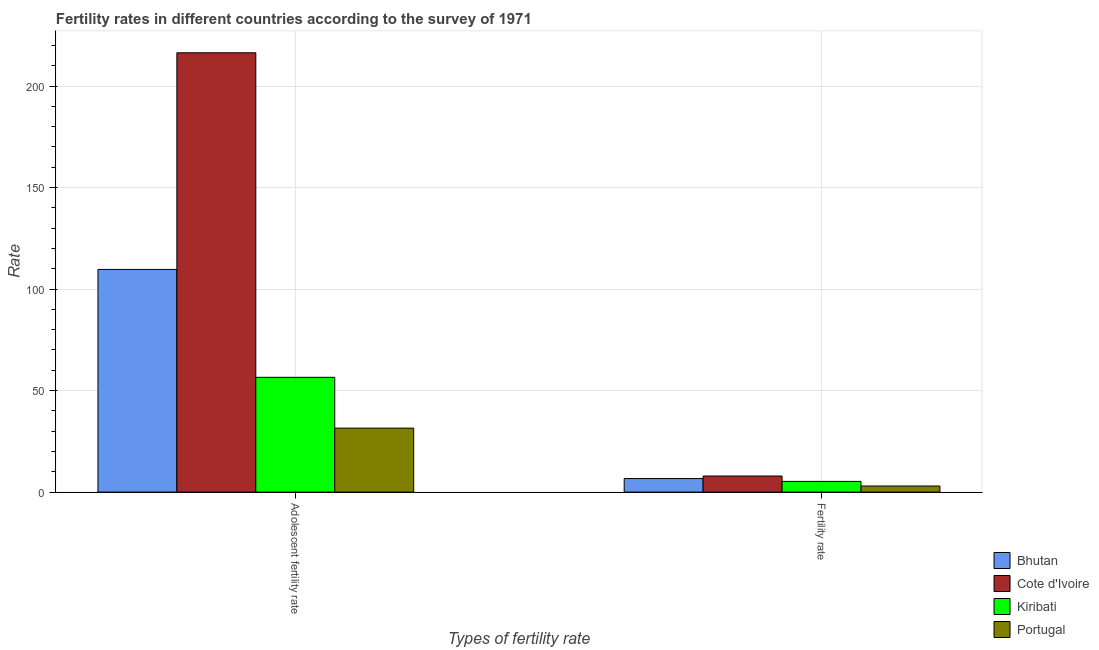Are the number of bars per tick equal to the number of legend labels?
Give a very brief answer. Yes. How many bars are there on the 1st tick from the right?
Ensure brevity in your answer.  4. What is the label of the 1st group of bars from the left?
Your response must be concise. Adolescent fertility rate. What is the adolescent fertility rate in Kiribati?
Ensure brevity in your answer.  56.53. Across all countries, what is the maximum fertility rate?
Offer a very short reply. 7.93. Across all countries, what is the minimum adolescent fertility rate?
Offer a very short reply. 31.51. In which country was the fertility rate maximum?
Your response must be concise. Cote d'Ivoire. What is the total fertility rate in the graph?
Your response must be concise. 22.87. What is the difference between the fertility rate in Portugal and that in Bhutan?
Your response must be concise. -3.67. What is the difference between the fertility rate in Kiribati and the adolescent fertility rate in Portugal?
Provide a succinct answer. -26.24. What is the average adolescent fertility rate per country?
Provide a succinct answer. 103.53. What is the difference between the adolescent fertility rate and fertility rate in Portugal?
Give a very brief answer. 28.51. In how many countries, is the adolescent fertility rate greater than 180 ?
Make the answer very short. 1. What is the ratio of the adolescent fertility rate in Cote d'Ivoire to that in Kiribati?
Make the answer very short. 3.83. Is the adolescent fertility rate in Cote d'Ivoire less than that in Bhutan?
Offer a very short reply. No. In how many countries, is the fertility rate greater than the average fertility rate taken over all countries?
Offer a terse response. 2. What does the 3rd bar from the left in Fertility rate represents?
Your answer should be compact. Kiribati. What does the 4th bar from the right in Fertility rate represents?
Ensure brevity in your answer.  Bhutan. How many bars are there?
Keep it short and to the point. 8. Are all the bars in the graph horizontal?
Offer a very short reply. No. What is the difference between two consecutive major ticks on the Y-axis?
Your answer should be compact. 50. Does the graph contain any zero values?
Your response must be concise. No. Where does the legend appear in the graph?
Give a very brief answer. Bottom right. How many legend labels are there?
Your answer should be compact. 4. How are the legend labels stacked?
Offer a terse response. Vertical. What is the title of the graph?
Offer a very short reply. Fertility rates in different countries according to the survey of 1971. What is the label or title of the X-axis?
Provide a short and direct response. Types of fertility rate. What is the label or title of the Y-axis?
Your answer should be compact. Rate. What is the Rate of Bhutan in Adolescent fertility rate?
Your answer should be very brief. 109.68. What is the Rate of Cote d'Ivoire in Adolescent fertility rate?
Make the answer very short. 216.39. What is the Rate of Kiribati in Adolescent fertility rate?
Your answer should be compact. 56.53. What is the Rate in Portugal in Adolescent fertility rate?
Provide a short and direct response. 31.51. What is the Rate in Bhutan in Fertility rate?
Give a very brief answer. 6.67. What is the Rate of Cote d'Ivoire in Fertility rate?
Your answer should be compact. 7.93. What is the Rate of Kiribati in Fertility rate?
Your answer should be compact. 5.27. What is the Rate of Portugal in Fertility rate?
Give a very brief answer. 3. Across all Types of fertility rate, what is the maximum Rate in Bhutan?
Provide a succinct answer. 109.68. Across all Types of fertility rate, what is the maximum Rate in Cote d'Ivoire?
Give a very brief answer. 216.39. Across all Types of fertility rate, what is the maximum Rate in Kiribati?
Your response must be concise. 56.53. Across all Types of fertility rate, what is the maximum Rate in Portugal?
Provide a succinct answer. 31.51. Across all Types of fertility rate, what is the minimum Rate in Bhutan?
Provide a succinct answer. 6.67. Across all Types of fertility rate, what is the minimum Rate of Cote d'Ivoire?
Provide a succinct answer. 7.93. Across all Types of fertility rate, what is the minimum Rate in Kiribati?
Provide a succinct answer. 5.27. Across all Types of fertility rate, what is the minimum Rate of Portugal?
Ensure brevity in your answer.  3. What is the total Rate of Bhutan in the graph?
Provide a short and direct response. 116.36. What is the total Rate in Cote d'Ivoire in the graph?
Your answer should be compact. 224.31. What is the total Rate in Kiribati in the graph?
Provide a succinct answer. 61.81. What is the total Rate of Portugal in the graph?
Your response must be concise. 34.51. What is the difference between the Rate in Bhutan in Adolescent fertility rate and that in Fertility rate?
Provide a succinct answer. 103.01. What is the difference between the Rate in Cote d'Ivoire in Adolescent fertility rate and that in Fertility rate?
Offer a very short reply. 208.46. What is the difference between the Rate of Kiribati in Adolescent fertility rate and that in Fertility rate?
Provide a short and direct response. 51.26. What is the difference between the Rate of Portugal in Adolescent fertility rate and that in Fertility rate?
Offer a very short reply. 28.51. What is the difference between the Rate in Bhutan in Adolescent fertility rate and the Rate in Cote d'Ivoire in Fertility rate?
Give a very brief answer. 101.75. What is the difference between the Rate in Bhutan in Adolescent fertility rate and the Rate in Kiribati in Fertility rate?
Offer a terse response. 104.41. What is the difference between the Rate in Bhutan in Adolescent fertility rate and the Rate in Portugal in Fertility rate?
Make the answer very short. 106.68. What is the difference between the Rate of Cote d'Ivoire in Adolescent fertility rate and the Rate of Kiribati in Fertility rate?
Offer a terse response. 211.11. What is the difference between the Rate of Cote d'Ivoire in Adolescent fertility rate and the Rate of Portugal in Fertility rate?
Keep it short and to the point. 213.39. What is the difference between the Rate of Kiribati in Adolescent fertility rate and the Rate of Portugal in Fertility rate?
Keep it short and to the point. 53.53. What is the average Rate in Bhutan per Types of fertility rate?
Provide a short and direct response. 58.18. What is the average Rate of Cote d'Ivoire per Types of fertility rate?
Your response must be concise. 112.16. What is the average Rate of Kiribati per Types of fertility rate?
Provide a short and direct response. 30.9. What is the average Rate in Portugal per Types of fertility rate?
Make the answer very short. 17.25. What is the difference between the Rate of Bhutan and Rate of Cote d'Ivoire in Adolescent fertility rate?
Give a very brief answer. -106.7. What is the difference between the Rate of Bhutan and Rate of Kiribati in Adolescent fertility rate?
Give a very brief answer. 53.15. What is the difference between the Rate of Bhutan and Rate of Portugal in Adolescent fertility rate?
Offer a terse response. 78.17. What is the difference between the Rate of Cote d'Ivoire and Rate of Kiribati in Adolescent fertility rate?
Your response must be concise. 159.85. What is the difference between the Rate in Cote d'Ivoire and Rate in Portugal in Adolescent fertility rate?
Provide a succinct answer. 184.88. What is the difference between the Rate in Kiribati and Rate in Portugal in Adolescent fertility rate?
Provide a short and direct response. 25.03. What is the difference between the Rate in Bhutan and Rate in Cote d'Ivoire in Fertility rate?
Offer a terse response. -1.25. What is the difference between the Rate in Bhutan and Rate in Kiribati in Fertility rate?
Give a very brief answer. 1.4. What is the difference between the Rate of Bhutan and Rate of Portugal in Fertility rate?
Give a very brief answer. 3.67. What is the difference between the Rate of Cote d'Ivoire and Rate of Kiribati in Fertility rate?
Make the answer very short. 2.65. What is the difference between the Rate of Cote d'Ivoire and Rate of Portugal in Fertility rate?
Offer a terse response. 4.93. What is the difference between the Rate in Kiribati and Rate in Portugal in Fertility rate?
Offer a terse response. 2.27. What is the ratio of the Rate of Bhutan in Adolescent fertility rate to that in Fertility rate?
Offer a very short reply. 16.43. What is the ratio of the Rate in Cote d'Ivoire in Adolescent fertility rate to that in Fertility rate?
Ensure brevity in your answer.  27.3. What is the ratio of the Rate in Kiribati in Adolescent fertility rate to that in Fertility rate?
Offer a very short reply. 10.72. What is the ratio of the Rate in Portugal in Adolescent fertility rate to that in Fertility rate?
Provide a succinct answer. 10.5. What is the difference between the highest and the second highest Rate of Bhutan?
Your answer should be compact. 103.01. What is the difference between the highest and the second highest Rate of Cote d'Ivoire?
Your answer should be very brief. 208.46. What is the difference between the highest and the second highest Rate in Kiribati?
Offer a terse response. 51.26. What is the difference between the highest and the second highest Rate of Portugal?
Give a very brief answer. 28.51. What is the difference between the highest and the lowest Rate in Bhutan?
Make the answer very short. 103.01. What is the difference between the highest and the lowest Rate in Cote d'Ivoire?
Keep it short and to the point. 208.46. What is the difference between the highest and the lowest Rate of Kiribati?
Ensure brevity in your answer.  51.26. What is the difference between the highest and the lowest Rate in Portugal?
Offer a very short reply. 28.51. 